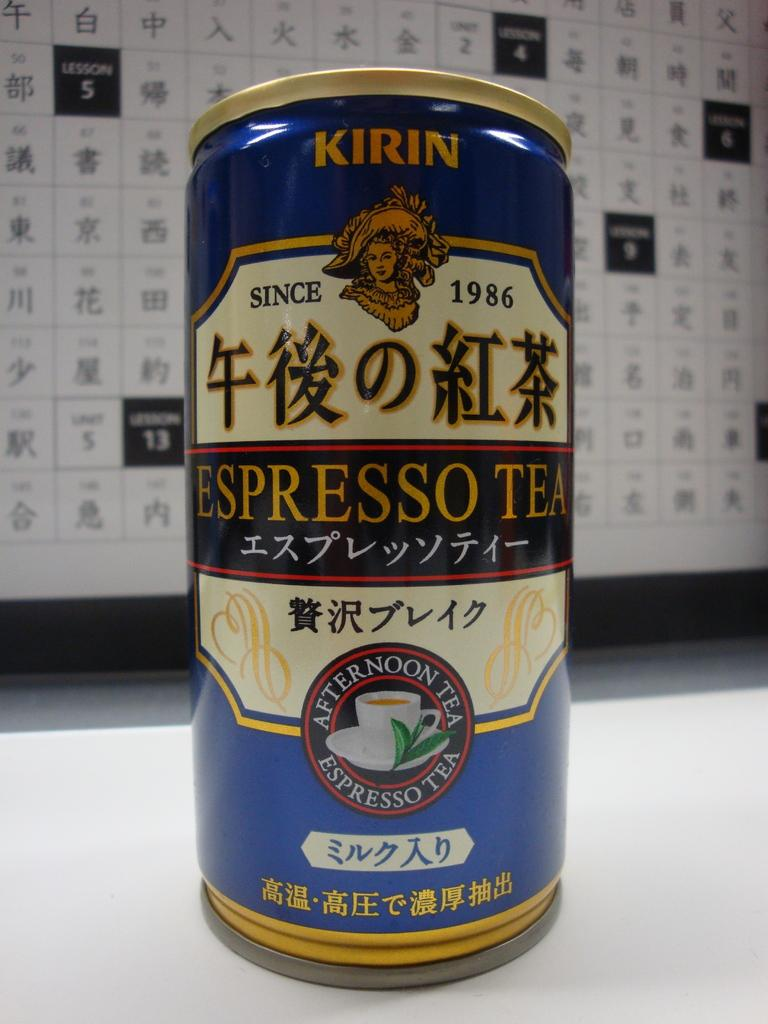What object is present on the table in the image? There is a tin on the table in the image. What is the color of the table? The table is white in color. What can be seen in the background of the image? There is a hoarding visible in the background of the image. Can you see any berries growing near the seashore in the image? There is no seashore or berries present in the image; it features a tin on a white table with a hoarding in the background. 